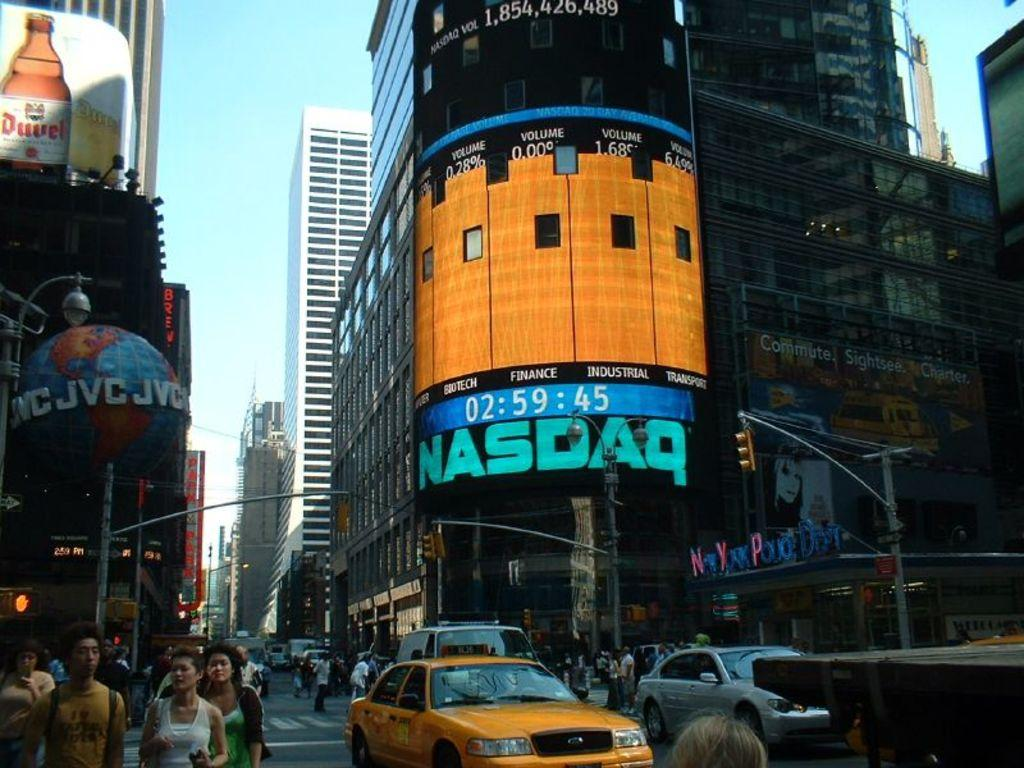What type of structures are visible in the image? The image contains buildings and skyscrapers. What is located at the bottom of the image? There is a road at the bottom of the image. What can be seen moving on the road? Cars are present on the road. Are there any people visible in the image? Yes, there are people walking on the road. What is visible at the top of the image? The sky is visible at the top of the image. What type of rabbit can be seen wearing apparel on its toe in the image? There is no rabbit or apparel on its toe present in the image. 